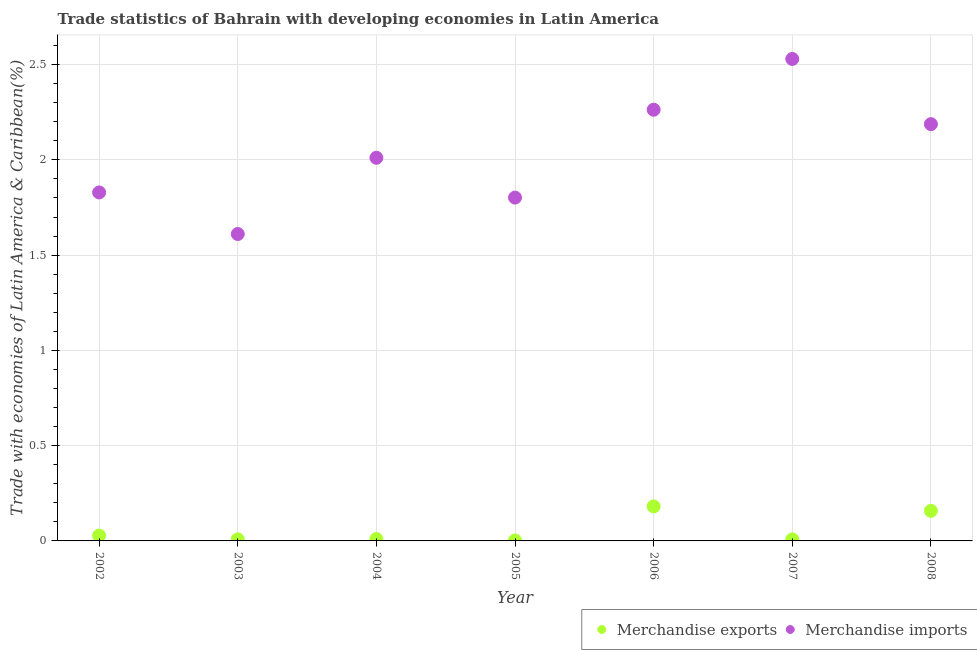How many different coloured dotlines are there?
Your answer should be compact. 2. What is the merchandise imports in 2008?
Offer a very short reply. 2.19. Across all years, what is the maximum merchandise exports?
Provide a short and direct response. 0.18. Across all years, what is the minimum merchandise exports?
Your answer should be compact. 0. In which year was the merchandise imports maximum?
Your answer should be very brief. 2007. What is the total merchandise exports in the graph?
Offer a terse response. 0.4. What is the difference between the merchandise exports in 2006 and that in 2007?
Offer a very short reply. 0.17. What is the difference between the merchandise exports in 2003 and the merchandise imports in 2005?
Provide a succinct answer. -1.79. What is the average merchandise imports per year?
Ensure brevity in your answer.  2.03. In the year 2004, what is the difference between the merchandise exports and merchandise imports?
Offer a terse response. -2. In how many years, is the merchandise imports greater than 2 %?
Make the answer very short. 4. What is the ratio of the merchandise exports in 2003 to that in 2006?
Ensure brevity in your answer.  0.05. Is the difference between the merchandise imports in 2005 and 2006 greater than the difference between the merchandise exports in 2005 and 2006?
Ensure brevity in your answer.  No. What is the difference between the highest and the second highest merchandise exports?
Your response must be concise. 0.02. What is the difference between the highest and the lowest merchandise imports?
Your response must be concise. 0.92. Is the sum of the merchandise imports in 2004 and 2006 greater than the maximum merchandise exports across all years?
Your answer should be very brief. Yes. Does the merchandise imports monotonically increase over the years?
Ensure brevity in your answer.  No. Is the merchandise exports strictly greater than the merchandise imports over the years?
Make the answer very short. No. Is the merchandise imports strictly less than the merchandise exports over the years?
Keep it short and to the point. No. How many dotlines are there?
Make the answer very short. 2. What is the difference between two consecutive major ticks on the Y-axis?
Offer a terse response. 0.5. Are the values on the major ticks of Y-axis written in scientific E-notation?
Provide a succinct answer. No. Does the graph contain any zero values?
Offer a terse response. No. What is the title of the graph?
Ensure brevity in your answer.  Trade statistics of Bahrain with developing economies in Latin America. Does "All education staff compensation" appear as one of the legend labels in the graph?
Ensure brevity in your answer.  No. What is the label or title of the Y-axis?
Keep it short and to the point. Trade with economies of Latin America & Caribbean(%). What is the Trade with economies of Latin America & Caribbean(%) of Merchandise exports in 2002?
Provide a short and direct response. 0.03. What is the Trade with economies of Latin America & Caribbean(%) of Merchandise imports in 2002?
Make the answer very short. 1.83. What is the Trade with economies of Latin America & Caribbean(%) in Merchandise exports in 2003?
Keep it short and to the point. 0.01. What is the Trade with economies of Latin America & Caribbean(%) in Merchandise imports in 2003?
Offer a terse response. 1.61. What is the Trade with economies of Latin America & Caribbean(%) of Merchandise exports in 2004?
Make the answer very short. 0.01. What is the Trade with economies of Latin America & Caribbean(%) of Merchandise imports in 2004?
Your answer should be compact. 2.01. What is the Trade with economies of Latin America & Caribbean(%) of Merchandise exports in 2005?
Your answer should be compact. 0. What is the Trade with economies of Latin America & Caribbean(%) in Merchandise imports in 2005?
Ensure brevity in your answer.  1.8. What is the Trade with economies of Latin America & Caribbean(%) in Merchandise exports in 2006?
Keep it short and to the point. 0.18. What is the Trade with economies of Latin America & Caribbean(%) in Merchandise imports in 2006?
Keep it short and to the point. 2.26. What is the Trade with economies of Latin America & Caribbean(%) of Merchandise exports in 2007?
Ensure brevity in your answer.  0.01. What is the Trade with economies of Latin America & Caribbean(%) in Merchandise imports in 2007?
Offer a terse response. 2.53. What is the Trade with economies of Latin America & Caribbean(%) in Merchandise exports in 2008?
Give a very brief answer. 0.16. What is the Trade with economies of Latin America & Caribbean(%) in Merchandise imports in 2008?
Keep it short and to the point. 2.19. Across all years, what is the maximum Trade with economies of Latin America & Caribbean(%) in Merchandise exports?
Your answer should be compact. 0.18. Across all years, what is the maximum Trade with economies of Latin America & Caribbean(%) in Merchandise imports?
Provide a succinct answer. 2.53. Across all years, what is the minimum Trade with economies of Latin America & Caribbean(%) of Merchandise exports?
Your response must be concise. 0. Across all years, what is the minimum Trade with economies of Latin America & Caribbean(%) in Merchandise imports?
Your response must be concise. 1.61. What is the total Trade with economies of Latin America & Caribbean(%) of Merchandise exports in the graph?
Give a very brief answer. 0.4. What is the total Trade with economies of Latin America & Caribbean(%) in Merchandise imports in the graph?
Make the answer very short. 14.23. What is the difference between the Trade with economies of Latin America & Caribbean(%) of Merchandise exports in 2002 and that in 2003?
Provide a short and direct response. 0.02. What is the difference between the Trade with economies of Latin America & Caribbean(%) in Merchandise imports in 2002 and that in 2003?
Your response must be concise. 0.22. What is the difference between the Trade with economies of Latin America & Caribbean(%) in Merchandise exports in 2002 and that in 2004?
Your answer should be compact. 0.02. What is the difference between the Trade with economies of Latin America & Caribbean(%) of Merchandise imports in 2002 and that in 2004?
Your response must be concise. -0.18. What is the difference between the Trade with economies of Latin America & Caribbean(%) of Merchandise exports in 2002 and that in 2005?
Offer a terse response. 0.03. What is the difference between the Trade with economies of Latin America & Caribbean(%) of Merchandise imports in 2002 and that in 2005?
Your answer should be very brief. 0.03. What is the difference between the Trade with economies of Latin America & Caribbean(%) of Merchandise exports in 2002 and that in 2006?
Your response must be concise. -0.15. What is the difference between the Trade with economies of Latin America & Caribbean(%) in Merchandise imports in 2002 and that in 2006?
Make the answer very short. -0.43. What is the difference between the Trade with economies of Latin America & Caribbean(%) of Merchandise exports in 2002 and that in 2007?
Offer a terse response. 0.02. What is the difference between the Trade with economies of Latin America & Caribbean(%) of Merchandise imports in 2002 and that in 2007?
Your answer should be compact. -0.7. What is the difference between the Trade with economies of Latin America & Caribbean(%) of Merchandise exports in 2002 and that in 2008?
Provide a succinct answer. -0.13. What is the difference between the Trade with economies of Latin America & Caribbean(%) of Merchandise imports in 2002 and that in 2008?
Offer a terse response. -0.36. What is the difference between the Trade with economies of Latin America & Caribbean(%) of Merchandise exports in 2003 and that in 2004?
Provide a succinct answer. -0. What is the difference between the Trade with economies of Latin America & Caribbean(%) of Merchandise imports in 2003 and that in 2004?
Provide a succinct answer. -0.4. What is the difference between the Trade with economies of Latin America & Caribbean(%) in Merchandise exports in 2003 and that in 2005?
Your answer should be compact. 0.01. What is the difference between the Trade with economies of Latin America & Caribbean(%) of Merchandise imports in 2003 and that in 2005?
Ensure brevity in your answer.  -0.19. What is the difference between the Trade with economies of Latin America & Caribbean(%) in Merchandise exports in 2003 and that in 2006?
Your answer should be very brief. -0.17. What is the difference between the Trade with economies of Latin America & Caribbean(%) of Merchandise imports in 2003 and that in 2006?
Provide a succinct answer. -0.65. What is the difference between the Trade with economies of Latin America & Caribbean(%) of Merchandise exports in 2003 and that in 2007?
Your response must be concise. 0. What is the difference between the Trade with economies of Latin America & Caribbean(%) of Merchandise imports in 2003 and that in 2007?
Offer a very short reply. -0.92. What is the difference between the Trade with economies of Latin America & Caribbean(%) of Merchandise exports in 2003 and that in 2008?
Offer a terse response. -0.15. What is the difference between the Trade with economies of Latin America & Caribbean(%) of Merchandise imports in 2003 and that in 2008?
Your response must be concise. -0.58. What is the difference between the Trade with economies of Latin America & Caribbean(%) of Merchandise exports in 2004 and that in 2005?
Your answer should be very brief. 0.01. What is the difference between the Trade with economies of Latin America & Caribbean(%) of Merchandise imports in 2004 and that in 2005?
Your answer should be compact. 0.21. What is the difference between the Trade with economies of Latin America & Caribbean(%) in Merchandise exports in 2004 and that in 2006?
Make the answer very short. -0.17. What is the difference between the Trade with economies of Latin America & Caribbean(%) of Merchandise imports in 2004 and that in 2006?
Give a very brief answer. -0.25. What is the difference between the Trade with economies of Latin America & Caribbean(%) in Merchandise exports in 2004 and that in 2007?
Provide a succinct answer. 0. What is the difference between the Trade with economies of Latin America & Caribbean(%) of Merchandise imports in 2004 and that in 2007?
Make the answer very short. -0.52. What is the difference between the Trade with economies of Latin America & Caribbean(%) of Merchandise exports in 2004 and that in 2008?
Ensure brevity in your answer.  -0.15. What is the difference between the Trade with economies of Latin America & Caribbean(%) in Merchandise imports in 2004 and that in 2008?
Provide a succinct answer. -0.18. What is the difference between the Trade with economies of Latin America & Caribbean(%) in Merchandise exports in 2005 and that in 2006?
Your response must be concise. -0.18. What is the difference between the Trade with economies of Latin America & Caribbean(%) of Merchandise imports in 2005 and that in 2006?
Your answer should be compact. -0.46. What is the difference between the Trade with economies of Latin America & Caribbean(%) in Merchandise exports in 2005 and that in 2007?
Keep it short and to the point. -0.01. What is the difference between the Trade with economies of Latin America & Caribbean(%) of Merchandise imports in 2005 and that in 2007?
Provide a succinct answer. -0.73. What is the difference between the Trade with economies of Latin America & Caribbean(%) in Merchandise exports in 2005 and that in 2008?
Provide a short and direct response. -0.16. What is the difference between the Trade with economies of Latin America & Caribbean(%) of Merchandise imports in 2005 and that in 2008?
Ensure brevity in your answer.  -0.39. What is the difference between the Trade with economies of Latin America & Caribbean(%) of Merchandise exports in 2006 and that in 2007?
Ensure brevity in your answer.  0.17. What is the difference between the Trade with economies of Latin America & Caribbean(%) of Merchandise imports in 2006 and that in 2007?
Your answer should be compact. -0.27. What is the difference between the Trade with economies of Latin America & Caribbean(%) in Merchandise exports in 2006 and that in 2008?
Give a very brief answer. 0.02. What is the difference between the Trade with economies of Latin America & Caribbean(%) of Merchandise imports in 2006 and that in 2008?
Keep it short and to the point. 0.08. What is the difference between the Trade with economies of Latin America & Caribbean(%) in Merchandise exports in 2007 and that in 2008?
Give a very brief answer. -0.15. What is the difference between the Trade with economies of Latin America & Caribbean(%) of Merchandise imports in 2007 and that in 2008?
Make the answer very short. 0.34. What is the difference between the Trade with economies of Latin America & Caribbean(%) of Merchandise exports in 2002 and the Trade with economies of Latin America & Caribbean(%) of Merchandise imports in 2003?
Provide a short and direct response. -1.58. What is the difference between the Trade with economies of Latin America & Caribbean(%) of Merchandise exports in 2002 and the Trade with economies of Latin America & Caribbean(%) of Merchandise imports in 2004?
Provide a short and direct response. -1.98. What is the difference between the Trade with economies of Latin America & Caribbean(%) of Merchandise exports in 2002 and the Trade with economies of Latin America & Caribbean(%) of Merchandise imports in 2005?
Offer a very short reply. -1.77. What is the difference between the Trade with economies of Latin America & Caribbean(%) in Merchandise exports in 2002 and the Trade with economies of Latin America & Caribbean(%) in Merchandise imports in 2006?
Make the answer very short. -2.24. What is the difference between the Trade with economies of Latin America & Caribbean(%) of Merchandise exports in 2002 and the Trade with economies of Latin America & Caribbean(%) of Merchandise imports in 2007?
Give a very brief answer. -2.5. What is the difference between the Trade with economies of Latin America & Caribbean(%) of Merchandise exports in 2002 and the Trade with economies of Latin America & Caribbean(%) of Merchandise imports in 2008?
Your answer should be compact. -2.16. What is the difference between the Trade with economies of Latin America & Caribbean(%) of Merchandise exports in 2003 and the Trade with economies of Latin America & Caribbean(%) of Merchandise imports in 2004?
Provide a succinct answer. -2. What is the difference between the Trade with economies of Latin America & Caribbean(%) in Merchandise exports in 2003 and the Trade with economies of Latin America & Caribbean(%) in Merchandise imports in 2005?
Make the answer very short. -1.79. What is the difference between the Trade with economies of Latin America & Caribbean(%) in Merchandise exports in 2003 and the Trade with economies of Latin America & Caribbean(%) in Merchandise imports in 2006?
Make the answer very short. -2.25. What is the difference between the Trade with economies of Latin America & Caribbean(%) of Merchandise exports in 2003 and the Trade with economies of Latin America & Caribbean(%) of Merchandise imports in 2007?
Provide a succinct answer. -2.52. What is the difference between the Trade with economies of Latin America & Caribbean(%) of Merchandise exports in 2003 and the Trade with economies of Latin America & Caribbean(%) of Merchandise imports in 2008?
Offer a very short reply. -2.18. What is the difference between the Trade with economies of Latin America & Caribbean(%) in Merchandise exports in 2004 and the Trade with economies of Latin America & Caribbean(%) in Merchandise imports in 2005?
Give a very brief answer. -1.79. What is the difference between the Trade with economies of Latin America & Caribbean(%) of Merchandise exports in 2004 and the Trade with economies of Latin America & Caribbean(%) of Merchandise imports in 2006?
Ensure brevity in your answer.  -2.25. What is the difference between the Trade with economies of Latin America & Caribbean(%) in Merchandise exports in 2004 and the Trade with economies of Latin America & Caribbean(%) in Merchandise imports in 2007?
Offer a terse response. -2.52. What is the difference between the Trade with economies of Latin America & Caribbean(%) in Merchandise exports in 2004 and the Trade with economies of Latin America & Caribbean(%) in Merchandise imports in 2008?
Your response must be concise. -2.18. What is the difference between the Trade with economies of Latin America & Caribbean(%) of Merchandise exports in 2005 and the Trade with economies of Latin America & Caribbean(%) of Merchandise imports in 2006?
Your answer should be compact. -2.26. What is the difference between the Trade with economies of Latin America & Caribbean(%) in Merchandise exports in 2005 and the Trade with economies of Latin America & Caribbean(%) in Merchandise imports in 2007?
Your response must be concise. -2.53. What is the difference between the Trade with economies of Latin America & Caribbean(%) of Merchandise exports in 2005 and the Trade with economies of Latin America & Caribbean(%) of Merchandise imports in 2008?
Offer a very short reply. -2.18. What is the difference between the Trade with economies of Latin America & Caribbean(%) of Merchandise exports in 2006 and the Trade with economies of Latin America & Caribbean(%) of Merchandise imports in 2007?
Make the answer very short. -2.35. What is the difference between the Trade with economies of Latin America & Caribbean(%) in Merchandise exports in 2006 and the Trade with economies of Latin America & Caribbean(%) in Merchandise imports in 2008?
Provide a succinct answer. -2.01. What is the difference between the Trade with economies of Latin America & Caribbean(%) in Merchandise exports in 2007 and the Trade with economies of Latin America & Caribbean(%) in Merchandise imports in 2008?
Your answer should be compact. -2.18. What is the average Trade with economies of Latin America & Caribbean(%) of Merchandise exports per year?
Keep it short and to the point. 0.06. What is the average Trade with economies of Latin America & Caribbean(%) in Merchandise imports per year?
Ensure brevity in your answer.  2.03. In the year 2002, what is the difference between the Trade with economies of Latin America & Caribbean(%) of Merchandise exports and Trade with economies of Latin America & Caribbean(%) of Merchandise imports?
Your answer should be very brief. -1.8. In the year 2003, what is the difference between the Trade with economies of Latin America & Caribbean(%) in Merchandise exports and Trade with economies of Latin America & Caribbean(%) in Merchandise imports?
Your answer should be very brief. -1.6. In the year 2004, what is the difference between the Trade with economies of Latin America & Caribbean(%) of Merchandise exports and Trade with economies of Latin America & Caribbean(%) of Merchandise imports?
Provide a short and direct response. -2. In the year 2005, what is the difference between the Trade with economies of Latin America & Caribbean(%) in Merchandise exports and Trade with economies of Latin America & Caribbean(%) in Merchandise imports?
Your answer should be compact. -1.8. In the year 2006, what is the difference between the Trade with economies of Latin America & Caribbean(%) in Merchandise exports and Trade with economies of Latin America & Caribbean(%) in Merchandise imports?
Provide a succinct answer. -2.08. In the year 2007, what is the difference between the Trade with economies of Latin America & Caribbean(%) in Merchandise exports and Trade with economies of Latin America & Caribbean(%) in Merchandise imports?
Ensure brevity in your answer.  -2.52. In the year 2008, what is the difference between the Trade with economies of Latin America & Caribbean(%) in Merchandise exports and Trade with economies of Latin America & Caribbean(%) in Merchandise imports?
Keep it short and to the point. -2.03. What is the ratio of the Trade with economies of Latin America & Caribbean(%) in Merchandise exports in 2002 to that in 2003?
Keep it short and to the point. 3.38. What is the ratio of the Trade with economies of Latin America & Caribbean(%) of Merchandise imports in 2002 to that in 2003?
Offer a very short reply. 1.14. What is the ratio of the Trade with economies of Latin America & Caribbean(%) of Merchandise exports in 2002 to that in 2004?
Provide a succinct answer. 2.79. What is the ratio of the Trade with economies of Latin America & Caribbean(%) of Merchandise imports in 2002 to that in 2004?
Your answer should be very brief. 0.91. What is the ratio of the Trade with economies of Latin America & Caribbean(%) in Merchandise exports in 2002 to that in 2005?
Keep it short and to the point. 10.71. What is the ratio of the Trade with economies of Latin America & Caribbean(%) of Merchandise imports in 2002 to that in 2005?
Offer a very short reply. 1.01. What is the ratio of the Trade with economies of Latin America & Caribbean(%) in Merchandise exports in 2002 to that in 2006?
Make the answer very short. 0.15. What is the ratio of the Trade with economies of Latin America & Caribbean(%) of Merchandise imports in 2002 to that in 2006?
Offer a terse response. 0.81. What is the ratio of the Trade with economies of Latin America & Caribbean(%) in Merchandise exports in 2002 to that in 2007?
Your answer should be very brief. 3.47. What is the ratio of the Trade with economies of Latin America & Caribbean(%) in Merchandise imports in 2002 to that in 2007?
Your response must be concise. 0.72. What is the ratio of the Trade with economies of Latin America & Caribbean(%) in Merchandise exports in 2002 to that in 2008?
Offer a terse response. 0.18. What is the ratio of the Trade with economies of Latin America & Caribbean(%) in Merchandise imports in 2002 to that in 2008?
Offer a very short reply. 0.84. What is the ratio of the Trade with economies of Latin America & Caribbean(%) of Merchandise exports in 2003 to that in 2004?
Keep it short and to the point. 0.83. What is the ratio of the Trade with economies of Latin America & Caribbean(%) of Merchandise imports in 2003 to that in 2004?
Offer a terse response. 0.8. What is the ratio of the Trade with economies of Latin America & Caribbean(%) of Merchandise exports in 2003 to that in 2005?
Your response must be concise. 3.17. What is the ratio of the Trade with economies of Latin America & Caribbean(%) in Merchandise imports in 2003 to that in 2005?
Give a very brief answer. 0.89. What is the ratio of the Trade with economies of Latin America & Caribbean(%) of Merchandise exports in 2003 to that in 2006?
Provide a short and direct response. 0.05. What is the ratio of the Trade with economies of Latin America & Caribbean(%) in Merchandise imports in 2003 to that in 2006?
Provide a short and direct response. 0.71. What is the ratio of the Trade with economies of Latin America & Caribbean(%) in Merchandise exports in 2003 to that in 2007?
Offer a terse response. 1.03. What is the ratio of the Trade with economies of Latin America & Caribbean(%) in Merchandise imports in 2003 to that in 2007?
Make the answer very short. 0.64. What is the ratio of the Trade with economies of Latin America & Caribbean(%) in Merchandise exports in 2003 to that in 2008?
Your answer should be very brief. 0.05. What is the ratio of the Trade with economies of Latin America & Caribbean(%) of Merchandise imports in 2003 to that in 2008?
Your response must be concise. 0.74. What is the ratio of the Trade with economies of Latin America & Caribbean(%) of Merchandise exports in 2004 to that in 2005?
Give a very brief answer. 3.84. What is the ratio of the Trade with economies of Latin America & Caribbean(%) of Merchandise imports in 2004 to that in 2005?
Offer a very short reply. 1.12. What is the ratio of the Trade with economies of Latin America & Caribbean(%) of Merchandise exports in 2004 to that in 2006?
Offer a terse response. 0.06. What is the ratio of the Trade with economies of Latin America & Caribbean(%) in Merchandise imports in 2004 to that in 2006?
Provide a short and direct response. 0.89. What is the ratio of the Trade with economies of Latin America & Caribbean(%) in Merchandise exports in 2004 to that in 2007?
Your answer should be very brief. 1.24. What is the ratio of the Trade with economies of Latin America & Caribbean(%) of Merchandise imports in 2004 to that in 2007?
Offer a very short reply. 0.79. What is the ratio of the Trade with economies of Latin America & Caribbean(%) in Merchandise exports in 2004 to that in 2008?
Offer a very short reply. 0.06. What is the ratio of the Trade with economies of Latin America & Caribbean(%) of Merchandise imports in 2004 to that in 2008?
Keep it short and to the point. 0.92. What is the ratio of the Trade with economies of Latin America & Caribbean(%) in Merchandise exports in 2005 to that in 2006?
Your answer should be very brief. 0.01. What is the ratio of the Trade with economies of Latin America & Caribbean(%) of Merchandise imports in 2005 to that in 2006?
Offer a very short reply. 0.8. What is the ratio of the Trade with economies of Latin America & Caribbean(%) of Merchandise exports in 2005 to that in 2007?
Make the answer very short. 0.32. What is the ratio of the Trade with economies of Latin America & Caribbean(%) of Merchandise imports in 2005 to that in 2007?
Ensure brevity in your answer.  0.71. What is the ratio of the Trade with economies of Latin America & Caribbean(%) in Merchandise exports in 2005 to that in 2008?
Ensure brevity in your answer.  0.02. What is the ratio of the Trade with economies of Latin America & Caribbean(%) of Merchandise imports in 2005 to that in 2008?
Offer a very short reply. 0.82. What is the ratio of the Trade with economies of Latin America & Caribbean(%) in Merchandise exports in 2006 to that in 2007?
Ensure brevity in your answer.  22.42. What is the ratio of the Trade with economies of Latin America & Caribbean(%) in Merchandise imports in 2006 to that in 2007?
Give a very brief answer. 0.89. What is the ratio of the Trade with economies of Latin America & Caribbean(%) in Merchandise exports in 2006 to that in 2008?
Your answer should be very brief. 1.15. What is the ratio of the Trade with economies of Latin America & Caribbean(%) in Merchandise imports in 2006 to that in 2008?
Keep it short and to the point. 1.03. What is the ratio of the Trade with economies of Latin America & Caribbean(%) in Merchandise exports in 2007 to that in 2008?
Offer a very short reply. 0.05. What is the ratio of the Trade with economies of Latin America & Caribbean(%) of Merchandise imports in 2007 to that in 2008?
Keep it short and to the point. 1.16. What is the difference between the highest and the second highest Trade with economies of Latin America & Caribbean(%) in Merchandise exports?
Your response must be concise. 0.02. What is the difference between the highest and the second highest Trade with economies of Latin America & Caribbean(%) of Merchandise imports?
Provide a short and direct response. 0.27. What is the difference between the highest and the lowest Trade with economies of Latin America & Caribbean(%) of Merchandise exports?
Provide a short and direct response. 0.18. What is the difference between the highest and the lowest Trade with economies of Latin America & Caribbean(%) in Merchandise imports?
Provide a short and direct response. 0.92. 